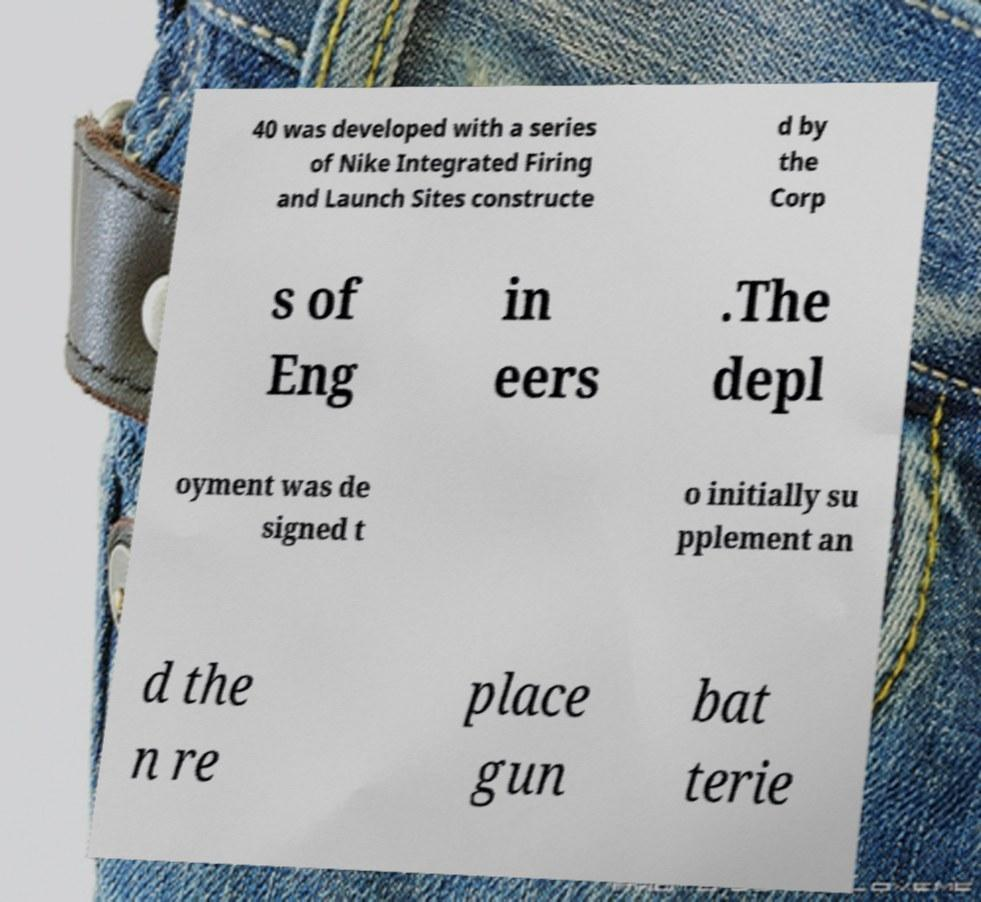What messages or text are displayed in this image? I need them in a readable, typed format. 40 was developed with a series of Nike Integrated Firing and Launch Sites constructe d by the Corp s of Eng in eers .The depl oyment was de signed t o initially su pplement an d the n re place gun bat terie 